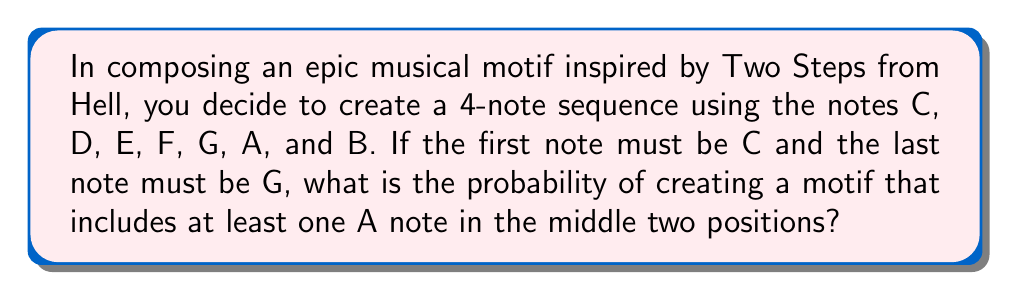Can you solve this math problem? Let's approach this step-by-step:

1) We have 4 note positions in total, but the first and last are fixed:
   C _ _ G

2) We need to fill the two middle positions. There are 7 possible notes for each position.

3) The total number of possible combinations for the two middle positions is:
   $7 \times 7 = 49$

4) Now, we need to calculate the number of combinations that include at least one A.

5) To do this, let's calculate the opposite: the number of combinations that don't include any A.
   Without A, we have 6 choices for each middle position: D, E, F, G, B, C

6) The number of combinations without A is:
   $6 \times 6 = 36$

7) Therefore, the number of combinations with at least one A is:
   $49 - 36 = 13$

8) The probability is the number of favorable outcomes divided by the total number of possible outcomes:

   $$P(\text{at least one A}) = \frac{13}{49}$$
Answer: $\frac{13}{49}$ 